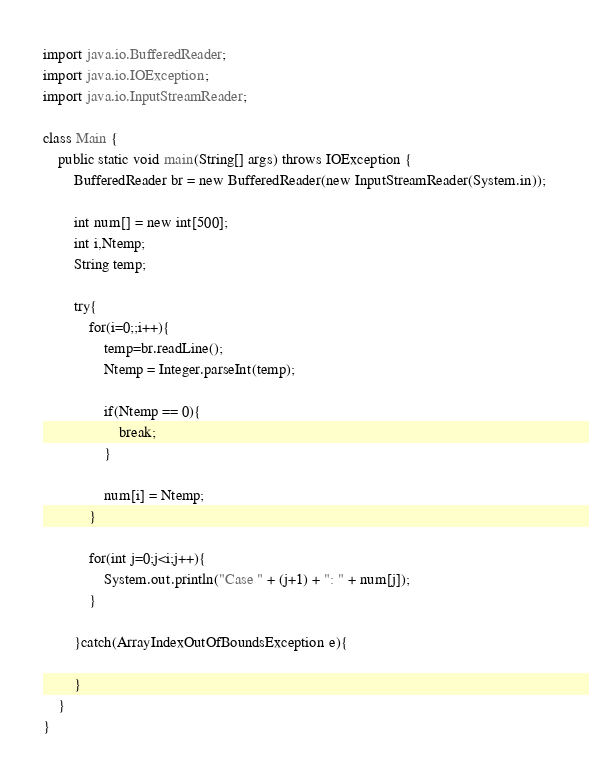Convert code to text. <code><loc_0><loc_0><loc_500><loc_500><_Java_>import java.io.BufferedReader;
import java.io.IOException;
import java.io.InputStreamReader;

class Main {
	public static void main(String[] args) throws IOException {
		BufferedReader br = new BufferedReader(new InputStreamReader(System.in));

		int num[] = new int[500];
		int i,Ntemp;
		String temp;

		try{
			for(i=0;;i++){
				temp=br.readLine();
				Ntemp = Integer.parseInt(temp);

				if(Ntemp == 0){
					break;
				}

				num[i] = Ntemp;
			}

			for(int j=0;j<i;j++){
				System.out.println("Case " + (j+1) + ": " + num[j]);
			}

		}catch(ArrayIndexOutOfBoundsException e){

		}
	}
}</code> 